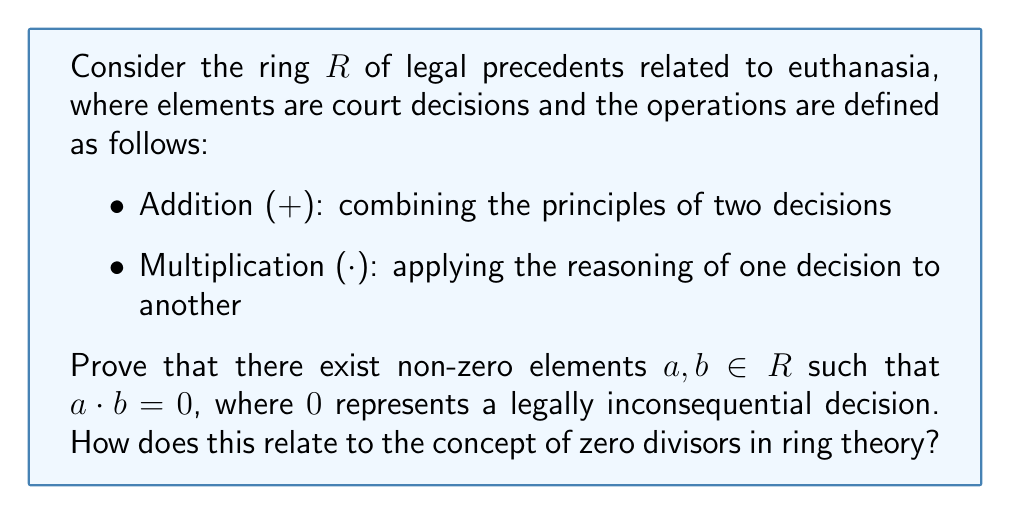Give your solution to this math problem. To prove the existence of zero divisors in the ring $R$ of legal precedents related to euthanasia, we need to show that there are non-zero elements whose product results in a legally inconsequential decision (the zero element). Let's approach this step-by-step:

1) First, let's consider two non-zero elements in $R$:
   $a$: A court decision supporting euthanasia in cases of terminal illness
   $b$: A court decision prohibiting euthanasia in all circumstances

2) Now, let's examine the product $a \cdot b$:
   This operation represents applying the reasoning of decision $a$ to decision $b$.

3) The result of this product would be a legal contradiction:
   - $a$ supports euthanasia in some cases
   - $b$ prohibits it in all cases
   - Applying $a$ to $b$ would result in a logically inconsistent and legally unenforceable decision

4) In the context of legal precedents, a contradictory or unenforceable decision is equivalent to no decision at all, which we define as the zero element in our ring.

5) Therefore, $a \cdot b = 0$, despite both $a$ and $b$ being non-zero elements.

6) This satisfies the definition of zero divisors in ring theory:
   In a ring $R$, non-zero elements $a$ and $b$ are zero divisors if $a \cdot b = 0$.

7) The existence of such elements in our ring of legal precedents demonstrates that it is not an integral domain, as integral domains do not have zero divisors.

This concept relates to the complexities in bioethics and end-of-life legal matters, where conflicting precedents can sometimes "cancel out" each other's legal weight, resulting in a situation where new legislation or higher court decisions are necessary to resolve the contradiction.
Answer: Zero divisors exist in the ring $R$ of legal precedents related to euthanasia. Specifically, there exist non-zero elements $a$ (supporting euthanasia in terminal illness cases) and $b$ (prohibiting euthanasia in all cases) such that $a \cdot b = 0$, where $0$ represents a legally inconsequential decision. This proves that $R$ is not an integral domain and highlights the potential for legal contradictions in complex bioethical issues. 